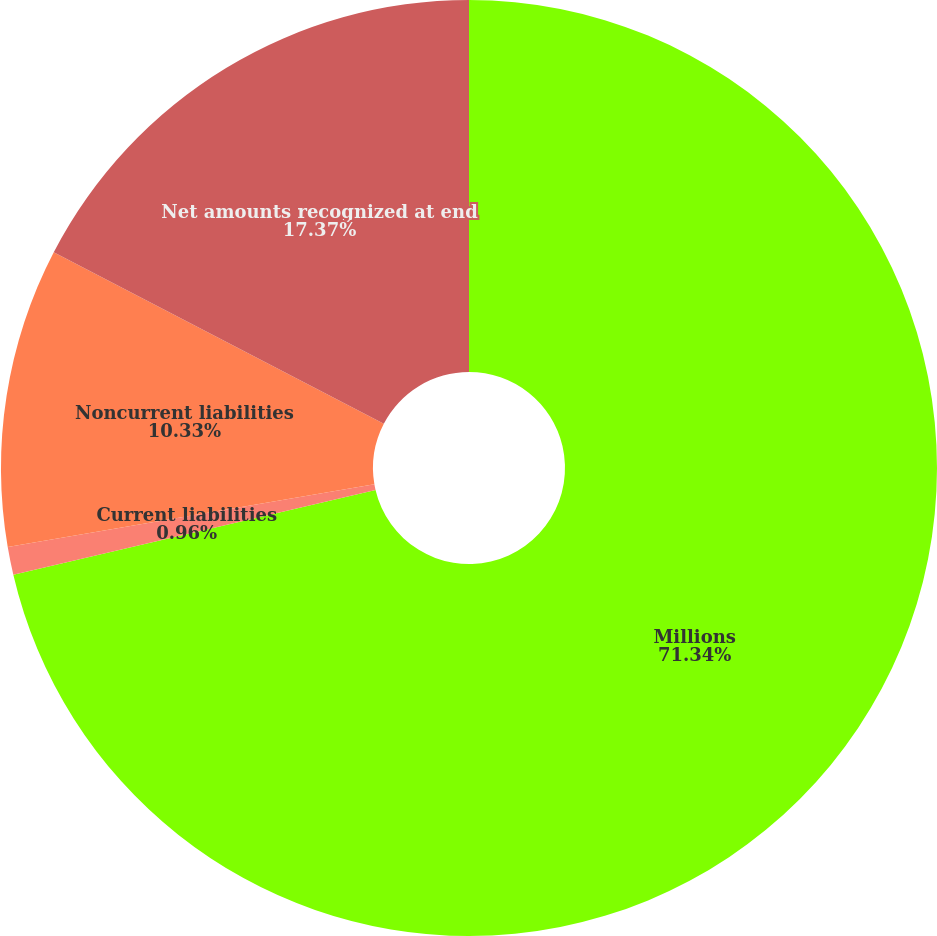<chart> <loc_0><loc_0><loc_500><loc_500><pie_chart><fcel>Millions<fcel>Current liabilities<fcel>Noncurrent liabilities<fcel>Net amounts recognized at end<nl><fcel>71.34%<fcel>0.96%<fcel>10.33%<fcel>17.37%<nl></chart> 